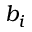Convert formula to latex. <formula><loc_0><loc_0><loc_500><loc_500>b _ { i }</formula> 